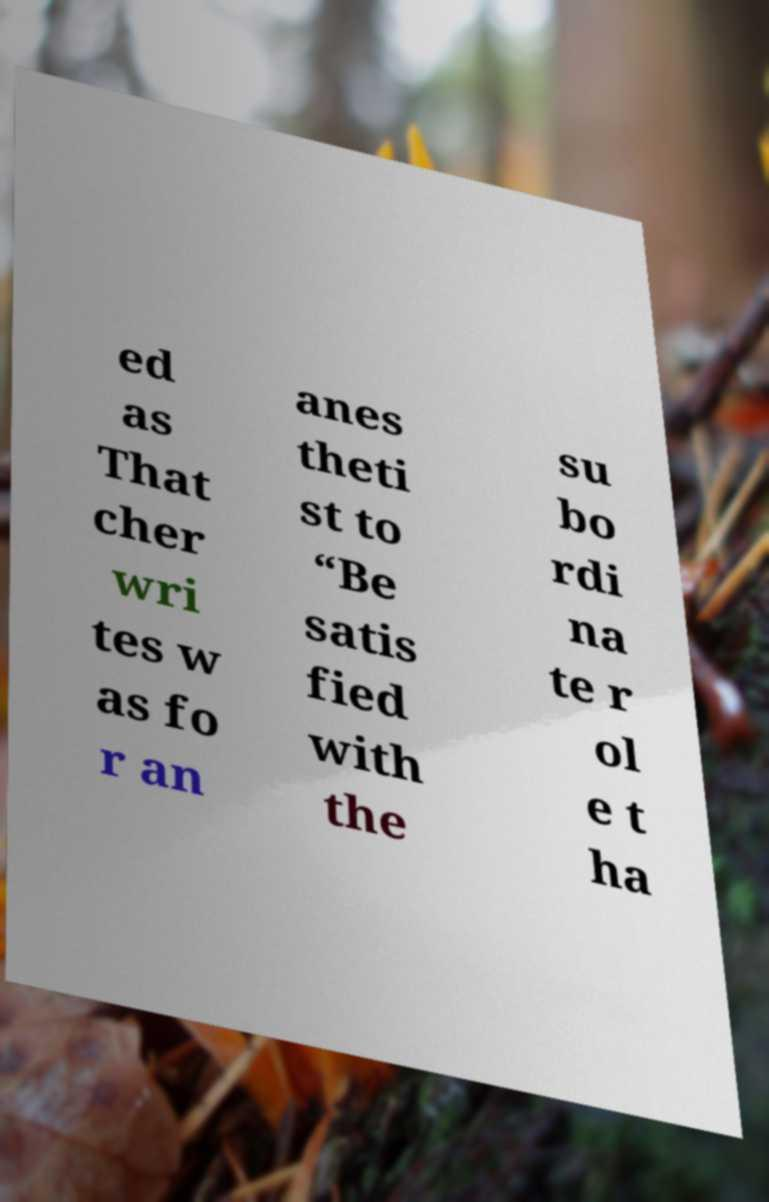Could you assist in decoding the text presented in this image and type it out clearly? ed as That cher wri tes w as fo r an anes theti st to “Be satis fied with the su bo rdi na te r ol e t ha 